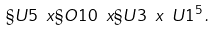<formula> <loc_0><loc_0><loc_500><loc_500>\S U 5 \ x \S O { 1 0 } \ x \S U 3 \ x \ U 1 ^ { 5 } \, .</formula> 